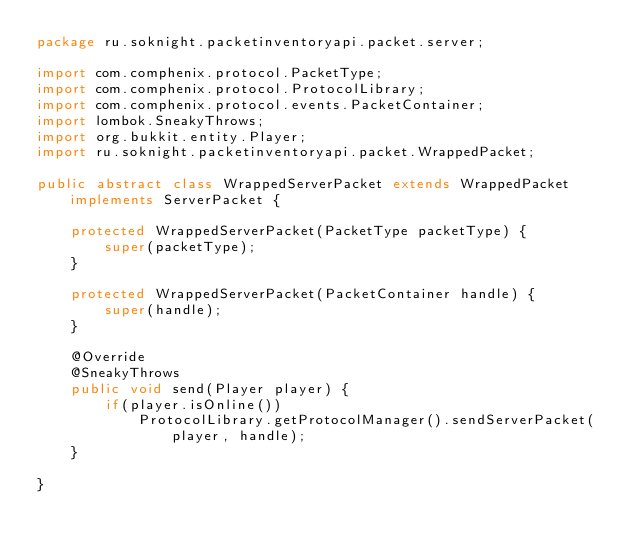Convert code to text. <code><loc_0><loc_0><loc_500><loc_500><_Java_>package ru.soknight.packetinventoryapi.packet.server;

import com.comphenix.protocol.PacketType;
import com.comphenix.protocol.ProtocolLibrary;
import com.comphenix.protocol.events.PacketContainer;
import lombok.SneakyThrows;
import org.bukkit.entity.Player;
import ru.soknight.packetinventoryapi.packet.WrappedPacket;

public abstract class WrappedServerPacket extends WrappedPacket implements ServerPacket {

    protected WrappedServerPacket(PacketType packetType) {
        super(packetType);
    }

    protected WrappedServerPacket(PacketContainer handle) {
        super(handle);
    }

    @Override
    @SneakyThrows
    public void send(Player player) {
        if(player.isOnline())
            ProtocolLibrary.getProtocolManager().sendServerPacket(player, handle);
    }

}
</code> 